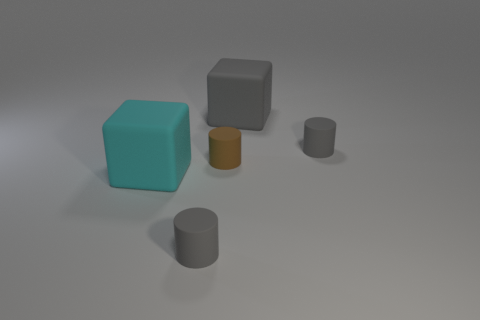Add 4 brown things. How many objects exist? 9 Subtract all cylinders. How many objects are left? 2 Add 3 tiny gray objects. How many tiny gray objects are left? 5 Add 2 rubber cylinders. How many rubber cylinders exist? 5 Subtract 0 purple blocks. How many objects are left? 5 Subtract all small matte cylinders. Subtract all small brown cylinders. How many objects are left? 1 